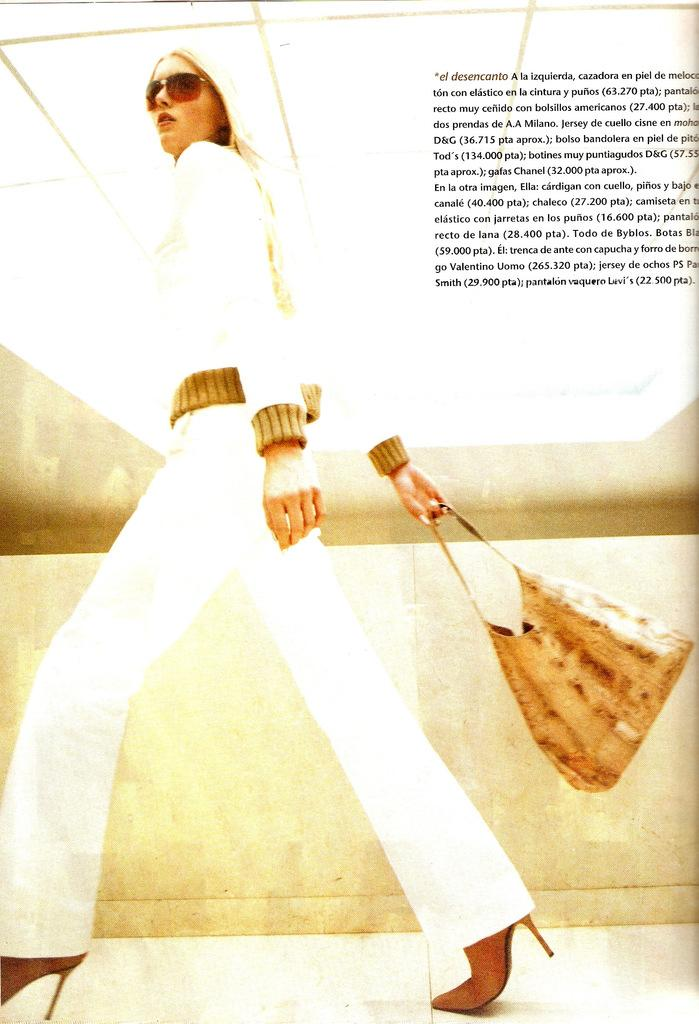Who is present in the image? There is a woman in the image. What is the woman holding in the image? The woman is holding a handbag. What can be seen behind the woman in the image? There is a wall behind the woman. Can you describe any text or symbols in the image? Yes, there is writing on the image. How does the woman attempt to put out the fire in the image? There is no fire present in the image, so the woman is not attempting to put it out. 